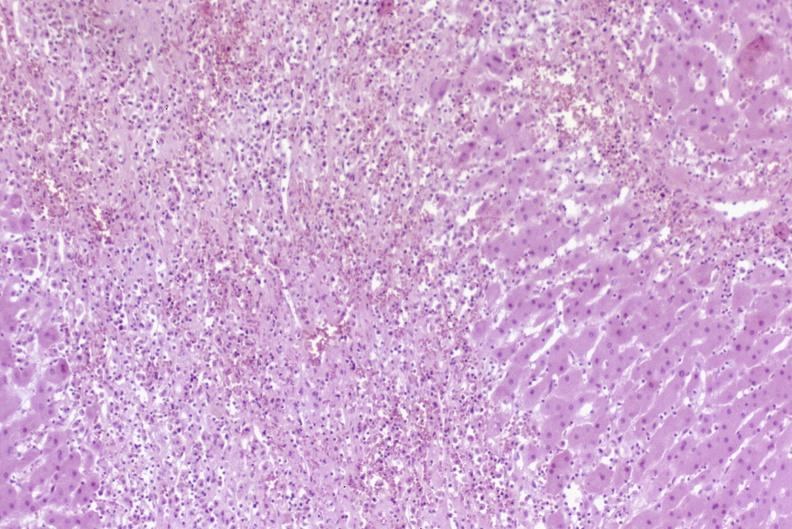s cat present?
Answer the question using a single word or phrase. No 